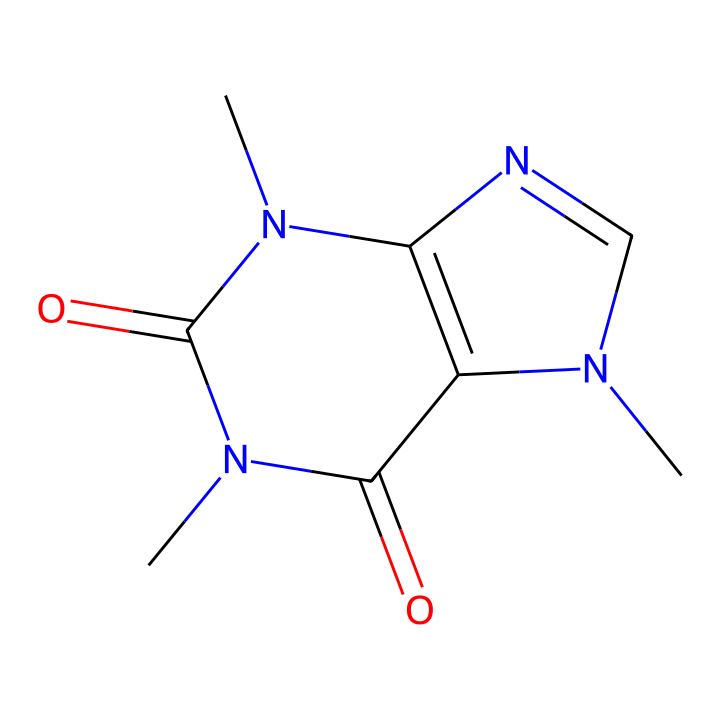What is the molecular formula of caffeine? The molecular formula can be derived from the SMILES notation by counting the number of each type of atom present. In the given SMILES, there are 8 carbon atoms, 10 hydrogen atoms, 4 nitrogen atoms, and 2 oxygen atoms, which gives the molecular formula C8H10N4O2.
Answer: C8H10N4O2 How many nitrogen atoms are present in caffeine? Counting the nitrogen atoms visible in the SMILES structure shows there are 4 nitrogen atoms. Each nitrogen is represented by 'N' in the notation.
Answer: 4 What kind of functional groups does caffeine contain? Caffeine has carbonyl groups (C=O) and nitrogen-containing groups (N), which are characteristic of its structure as an alkaloid. These functional groups influence its biological activity.
Answer: carbonyl, nitrogen Is caffeine a solid, liquid, or gas at room temperature? Caffeine is known to be a solid at room temperature, commonly found as a white crystalline powder. This is a result of its specific molecular structure and intermolecular forces.
Answer: solid What is the role of caffeine in sports performance? Caffeine acts as a stimulant, enhancing physical performance by increasing alertness and reducing the perception of effort, which has been extensively researched in sports science.
Answer: stimulant What type of compound is caffeine categorized as? Caffeine is categorized as an alkaloid due to its nitrogen-containing structure and notable effects on the body, particularly as a stimulant that can enhance performance in various activities.
Answer: alkaloid What is the number of rings in the structure of caffeine? By analyzing the cyclic parts of the SMILES representation, one can count the rings present in caffeine. In this case, there are 2 distinct rings indicated by the numbers in the SMILES.
Answer: 2 